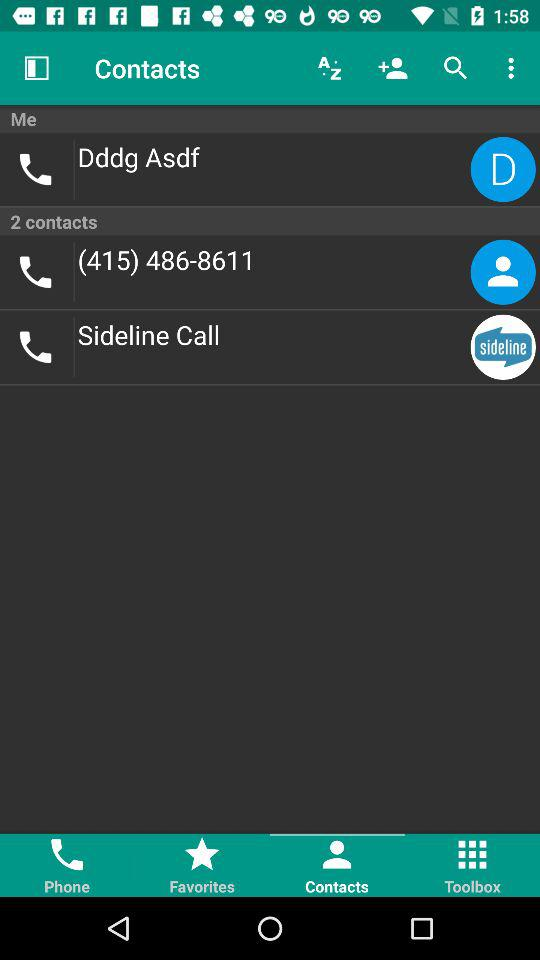How many contacts are there? There are 2 contacts. 